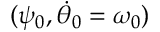Convert formula to latex. <formula><loc_0><loc_0><loc_500><loc_500>( \psi _ { 0 } , \dot { \theta } _ { 0 } = \omega _ { 0 } )</formula> 